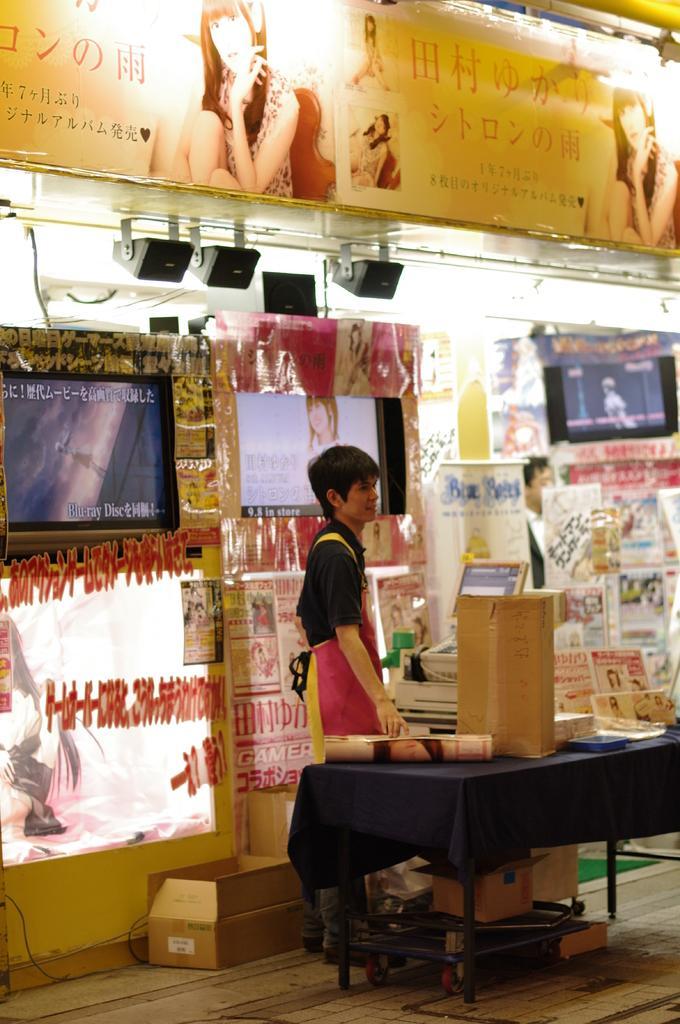Could you give a brief overview of what you see in this image? The person wearing black shirt is standing and there is a table in front of him which consist of some objects, In background there are televisions. 